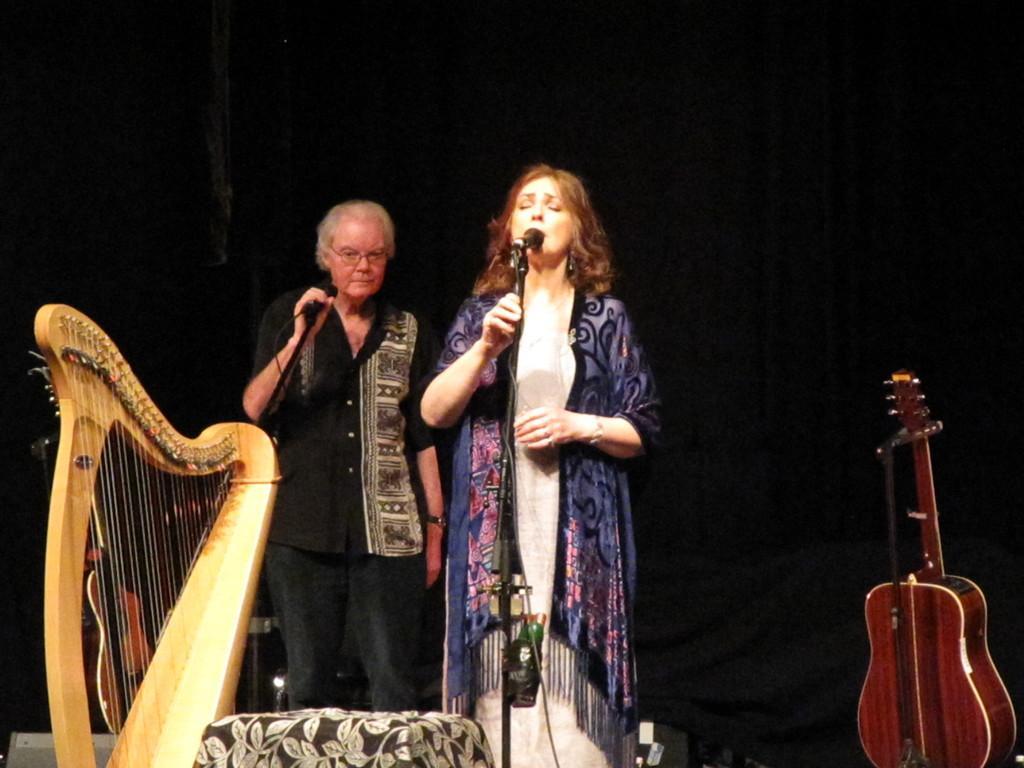Could you give a brief overview of what you see in this image? In this image I can see two people and also few musical instruments. I can see a mic in front of a woman. 